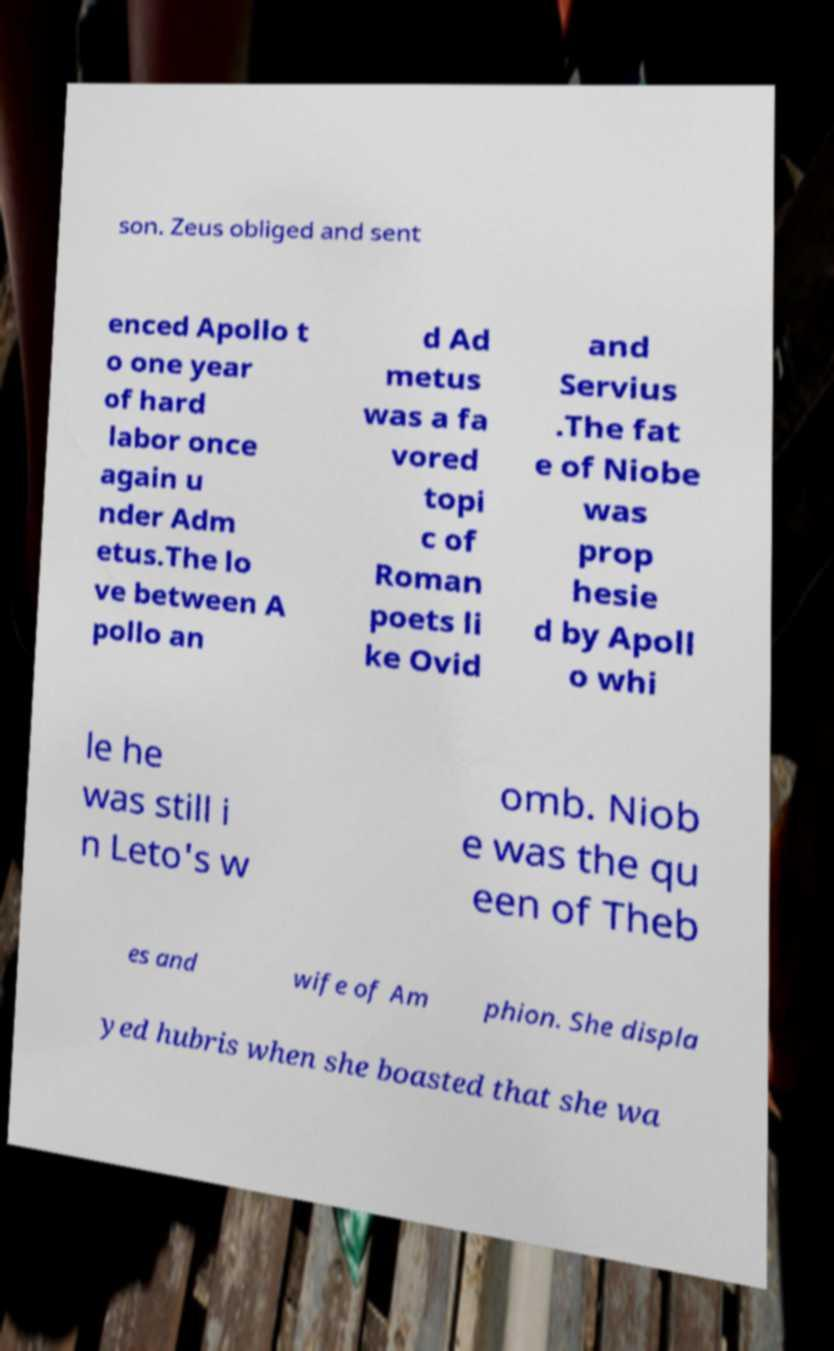Could you extract and type out the text from this image? son. Zeus obliged and sent enced Apollo t o one year of hard labor once again u nder Adm etus.The lo ve between A pollo an d Ad metus was a fa vored topi c of Roman poets li ke Ovid and Servius .The fat e of Niobe was prop hesie d by Apoll o whi le he was still i n Leto's w omb. Niob e was the qu een of Theb es and wife of Am phion. She displa yed hubris when she boasted that she wa 